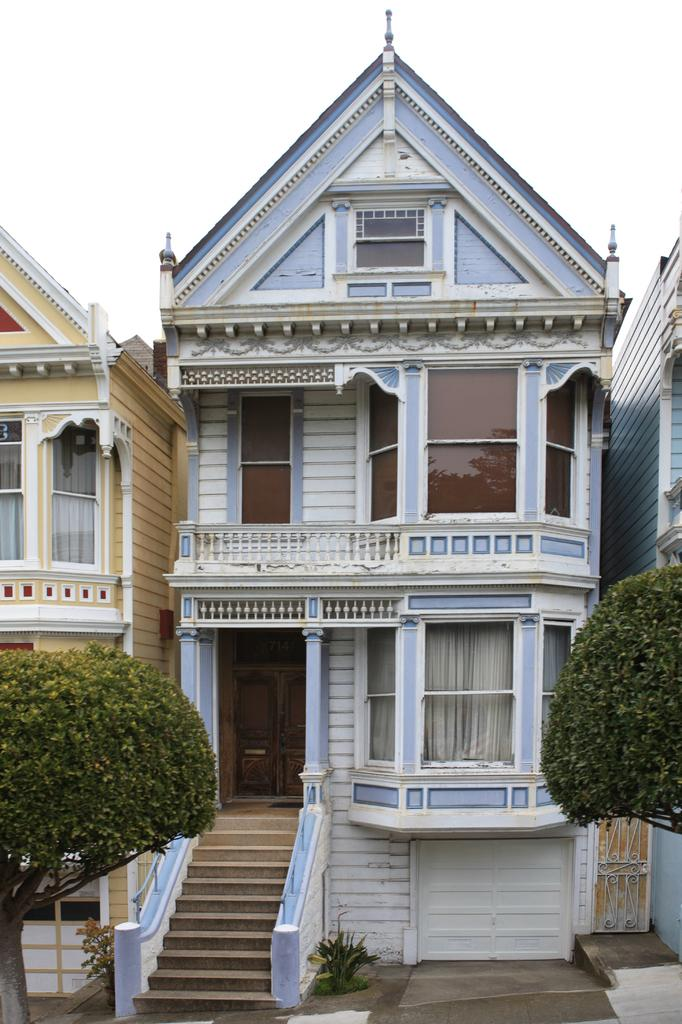What type of structures can be seen in the image? There are buildings in the image. What architectural feature is present in the image? There are stairs in the image. What type of vegetation is visible in the image? There are plants and trees in the image. What part of the natural environment is visible in the image? The sky is visible in the image. What type of lead can be seen in the image? There is no lead present in the image. How does the image show respect for the environment? The image does not show respect for the environment; it simply depicts buildings, stairs, plants, trees, and the sky. Where is the drawer located in the image? There is no drawer present in the image. 